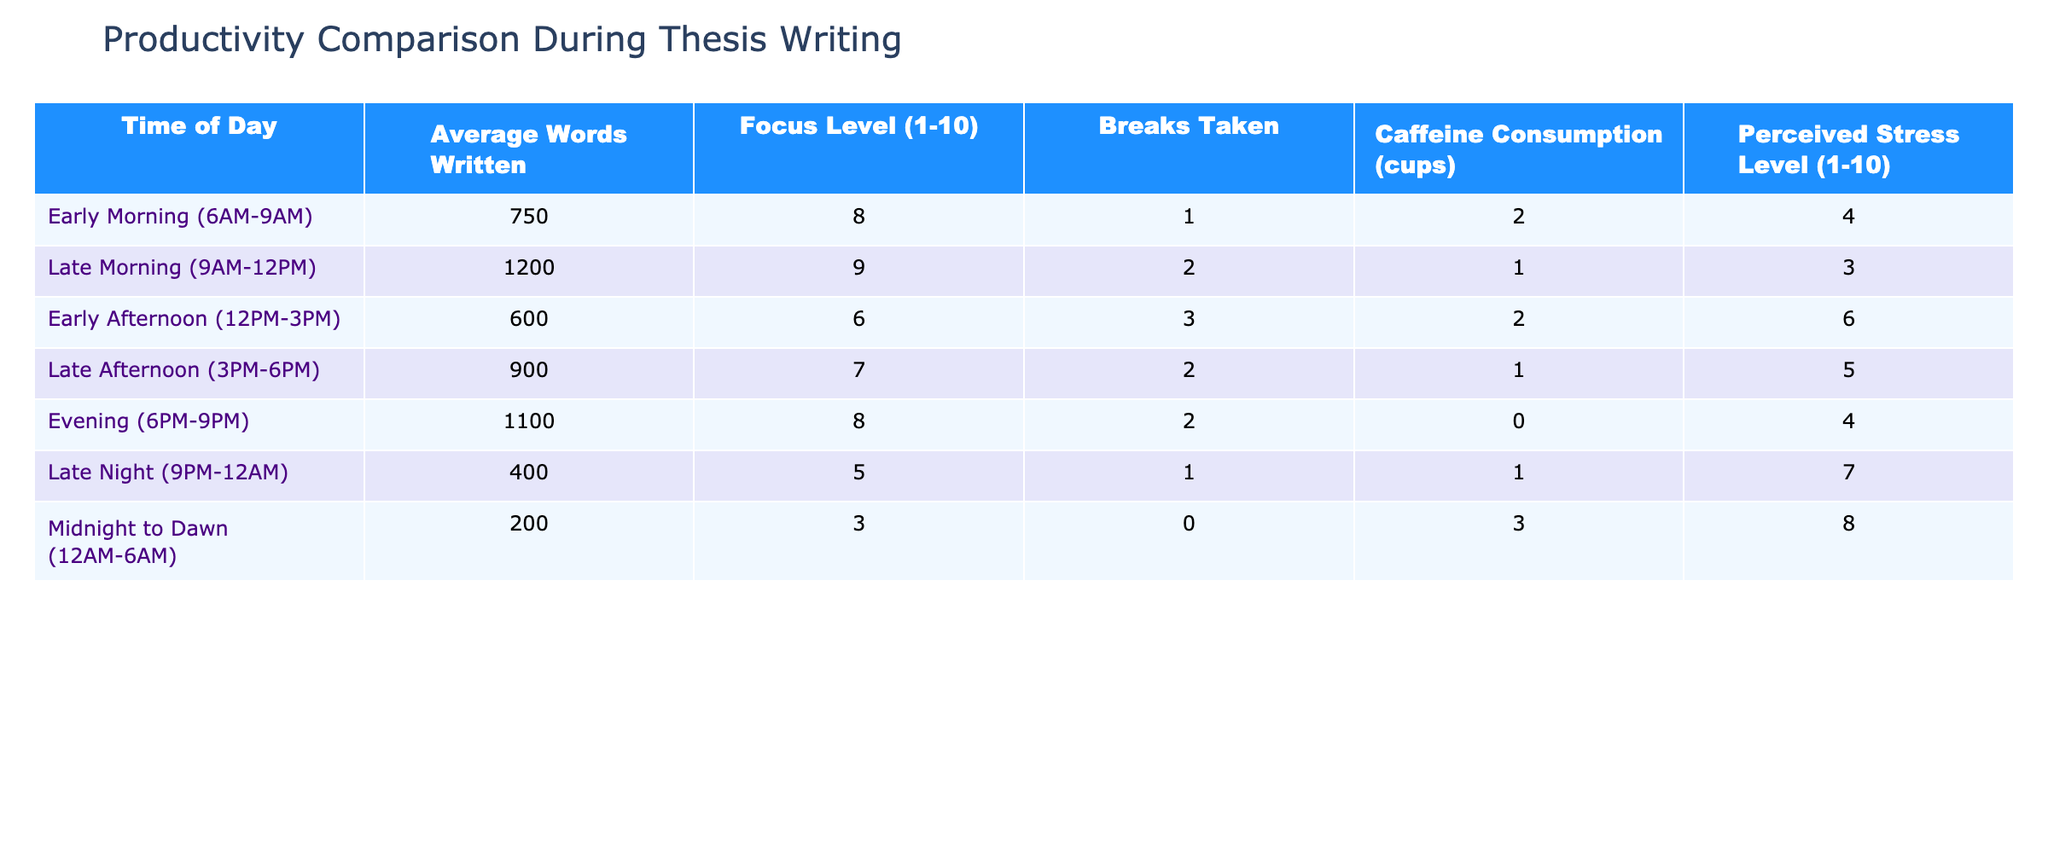What is the time of day with the highest average words written? By examining the "Average Words Written" column, the highest value is 1200, which corresponds to the "Late Morning (9AM-12PM)" time period.
Answer: Late Morning (9AM-12PM) What is the average focus level during the Early Afternoon (12PM-3PM)? The focus level for the Early Afternoon (12PM-3PM) is specifically recorded as 6, which is directly taken from the "Focus Level (1-10)" column for that time period.
Answer: 6 Which time of day has the lowest perceived stress level? Looking for the lowest value in the "Perceived Stress Level (1-10)" column indicates that "Late Morning (9AM-12PM)" has the lowest value of 3, which can be confirmed by scanning the entire column for the minimum.
Answer: Late Morning (9AM-12PM) What is the total number of breaks taken during the afternoon (12PM-6PM) time periods? We add the breaks from both "Early Afternoon (12PM-3PM)" and "Late Afternoon (3PM-6PM)" which are 3 and 2 respectively. This totals to 3 + 2 = 5 breaks taken.
Answer: 5 Is caffeine consumption higher in the Evening (6PM-9PM) than in the Late Night (9PM-12AM)? The caffeine consumption for the Evening is recorded as 0 cups, while for the Late Night it's 1 cup. Thus, the statement is false as 0 is not higher than 1.
Answer: No Which time frame exhibits both the highest average words written and the highest focus level? Checking the "Average Words Written" and "Focus Level" columns, "Late Morning (9AM-12PM)" has the highest average words at 1200 and a focus level of 9, which are both the maximum values in their respective entries.
Answer: Late Morning (9AM-12PM) How does the average perceived stress level in the Midnight to Dawn (12AM-6AM) time frame compare to that of the Early Morning (6AM-9AM)? The perceived stress for "Midnight to Dawn" is 8 and for "Early Morning" it is 4. To compare them, we observe that 8 is greater than 4, thus indicating higher stress during the later time.
Answer: Higher What is the difference in average words written between the Late Morning (9AM-12PM) and the Early Afternoon (12PM-3PM)? The average words for Late Morning is 1200 and for Early Afternoon is 600. The difference can be calculated by taking 1200 - 600 = 600 words.
Answer: 600 Which time of day has the highest number of breaks taken? Analyzing the "Breaks Taken" column, the maximum number of breaks is 3, found during the "Early Afternoon (12PM-3PM)" period.
Answer: Early Afternoon (12PM-3PM) 